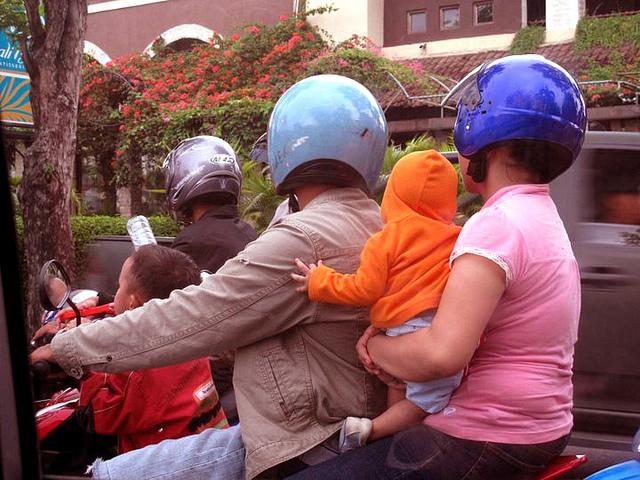How many people are on the bike?
Give a very brief answer. 4. Does the passenger have a shirt on?
Write a very short answer. Yes. How many helmets are there?
Quick response, please. 3. What color is the jacket on the baby?
Quick response, please. Orange. What are the people sitting on?
Short answer required. Motorcycle. 